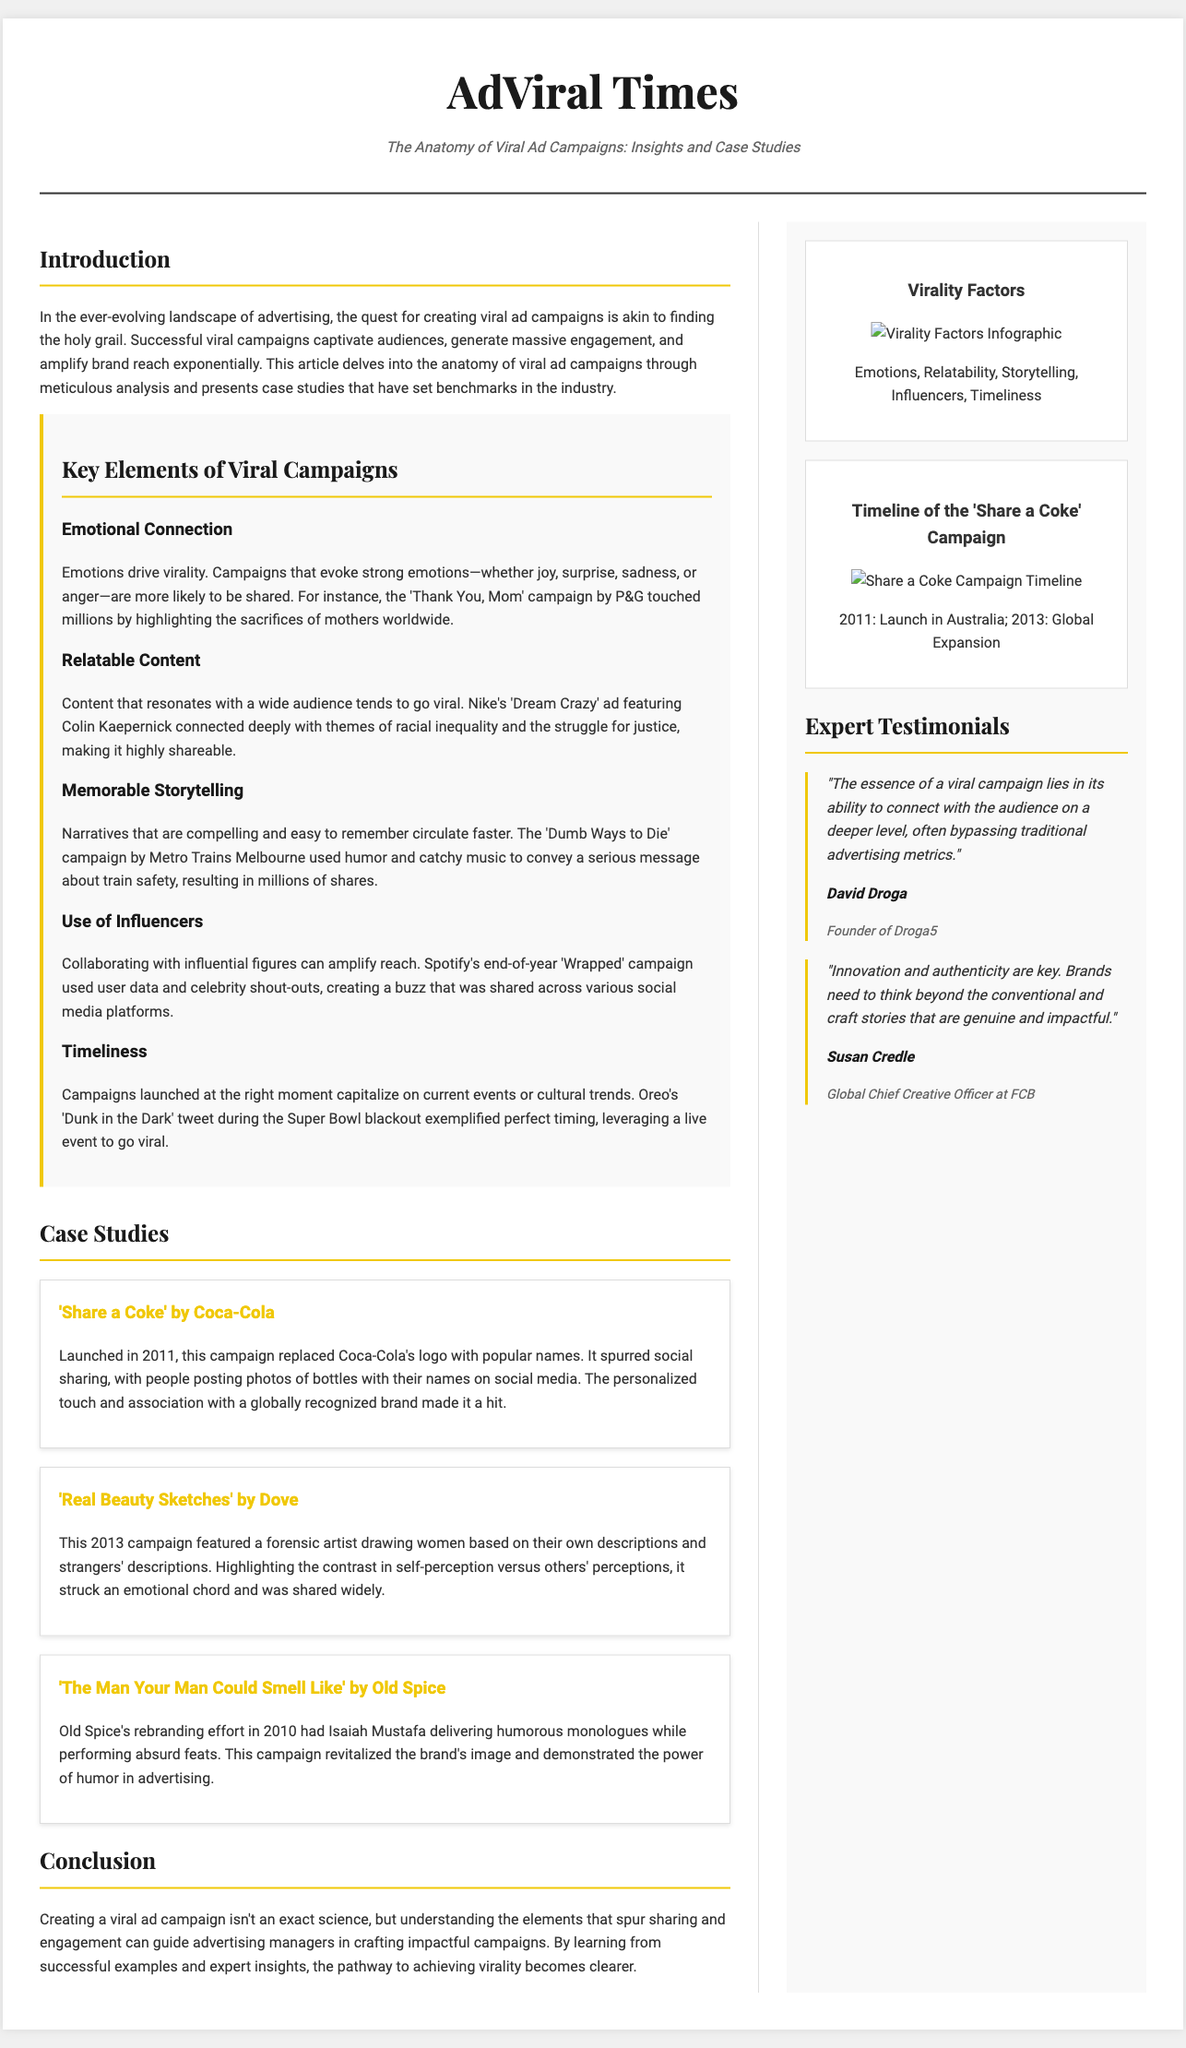what is the title of the article? The title of the article is found at the top of the document, which refers to the specific focus of the content.
Answer: The Anatomy of Viral Ad Campaigns: Insights and Case Studies who is the founder of Droga5? This is mentioned in the expert testimonials section, identifying the individual associated with the agency.
Answer: David Droga what year did the 'Share a Coke' campaign launch in Australia? The document specifies the launch year of the campaign, providing a specific date of inception.
Answer: 2011 which brand featured the 'Real Beauty Sketches' campaign? This refers to the case studies outlined in the document, specifying the brand associated with a significant advertising initiative.
Answer: Dove what emotional element is highlighted as a key component of viral campaigns? The document discusses various elements necessary for virality, emphasizing emotions' role in driving shares.
Answer: Emotional Connection what marketing strategy did Spotify's 'Wrapped' campaign use? This can be inferred from the key elements section discussing collaborations that amplify reach.
Answer: Use of Influencers how many case studies are presented in the document? The number of case studies can be counted in the respective section elaborating on successful campaigns.
Answer: Three which campaign is associated with the slogan 'The Man Your Man Could Smell Like'? This campaign is detailed in the case study section, showing brand rebranding efforts through a specific slogan.
Answer: Old Spice what critical factor does Susan Credle emphasize in her testimonial? The expert quote section illustrates key insights from industry leaders regarding successful advertising practices.
Answer: Innovation and authenticity 